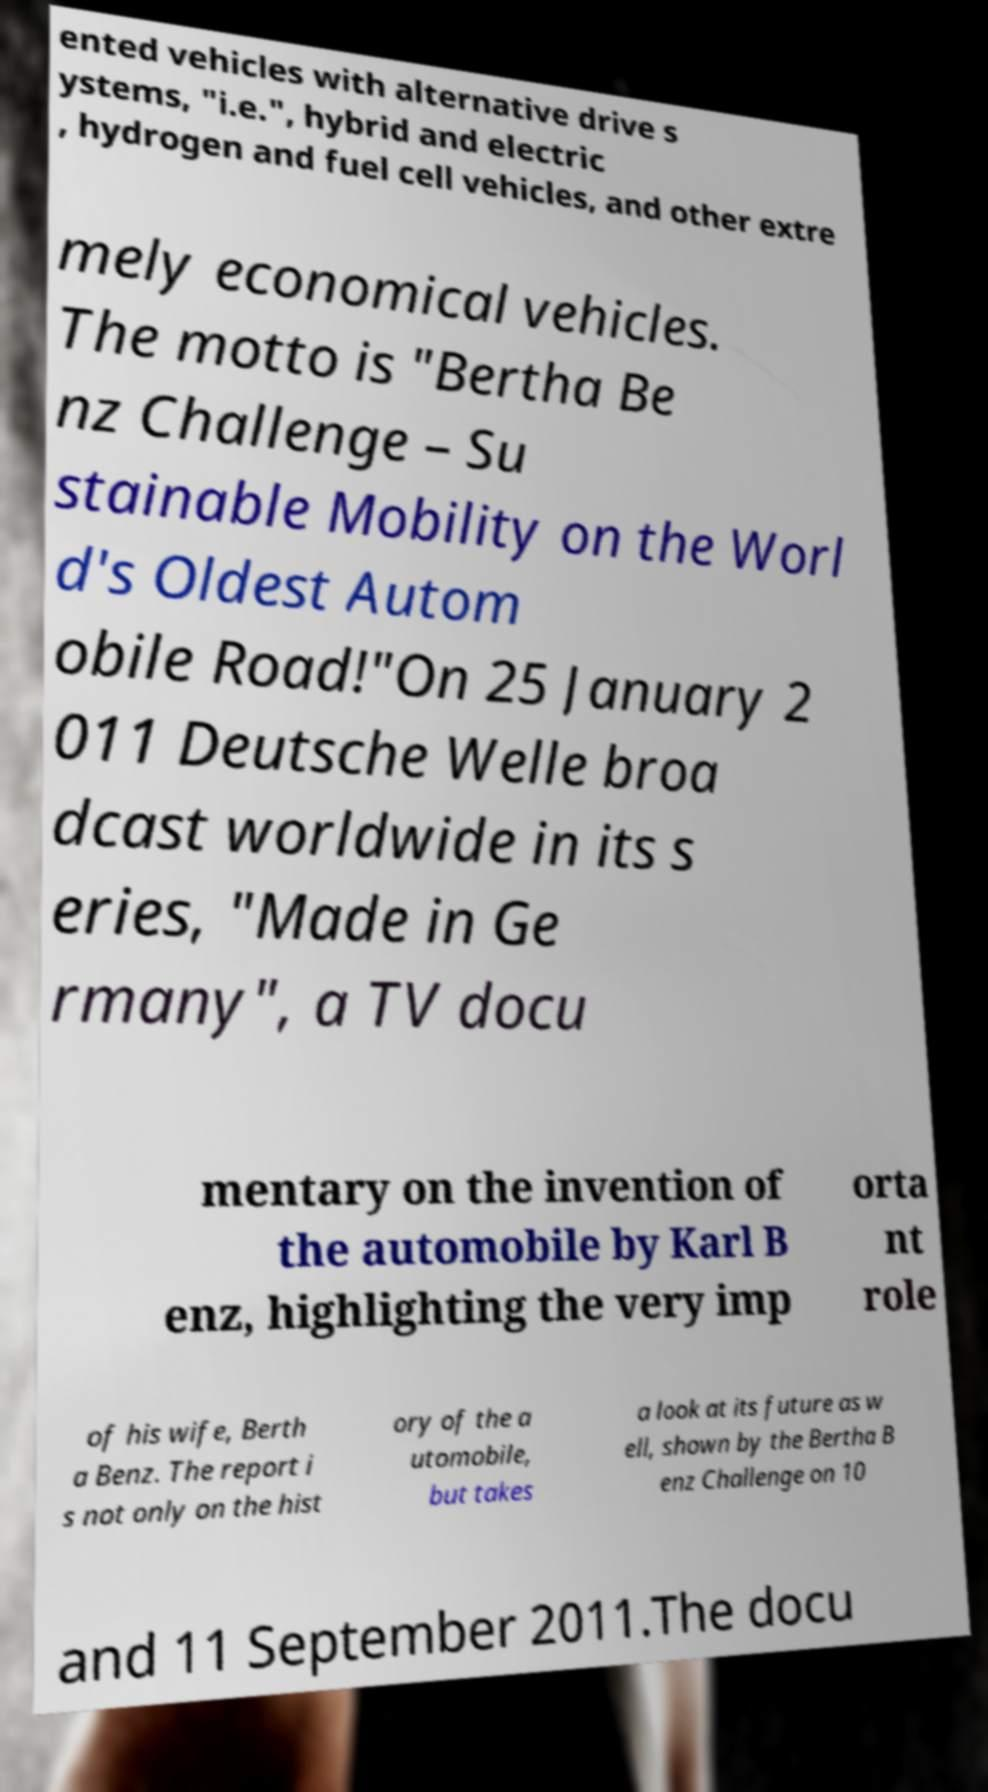Could you assist in decoding the text presented in this image and type it out clearly? ented vehicles with alternative drive s ystems, "i.e.", hybrid and electric , hydrogen and fuel cell vehicles, and other extre mely economical vehicles. The motto is "Bertha Be nz Challenge – Su stainable Mobility on the Worl d's Oldest Autom obile Road!"On 25 January 2 011 Deutsche Welle broa dcast worldwide in its s eries, "Made in Ge rmany", a TV docu mentary on the invention of the automobile by Karl B enz, highlighting the very imp orta nt role of his wife, Berth a Benz. The report i s not only on the hist ory of the a utomobile, but takes a look at its future as w ell, shown by the Bertha B enz Challenge on 10 and 11 September 2011.The docu 